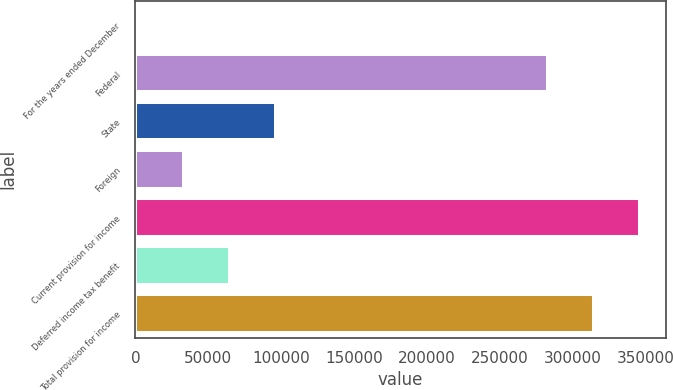Convert chart. <chart><loc_0><loc_0><loc_500><loc_500><bar_chart><fcel>For the years ended December<fcel>Federal<fcel>State<fcel>Foreign<fcel>Current provision for income<fcel>Deferred income tax benefit<fcel>Total provision for income<nl><fcel>2010<fcel>283449<fcel>96722.7<fcel>33580.9<fcel>346591<fcel>65151.8<fcel>315020<nl></chart> 